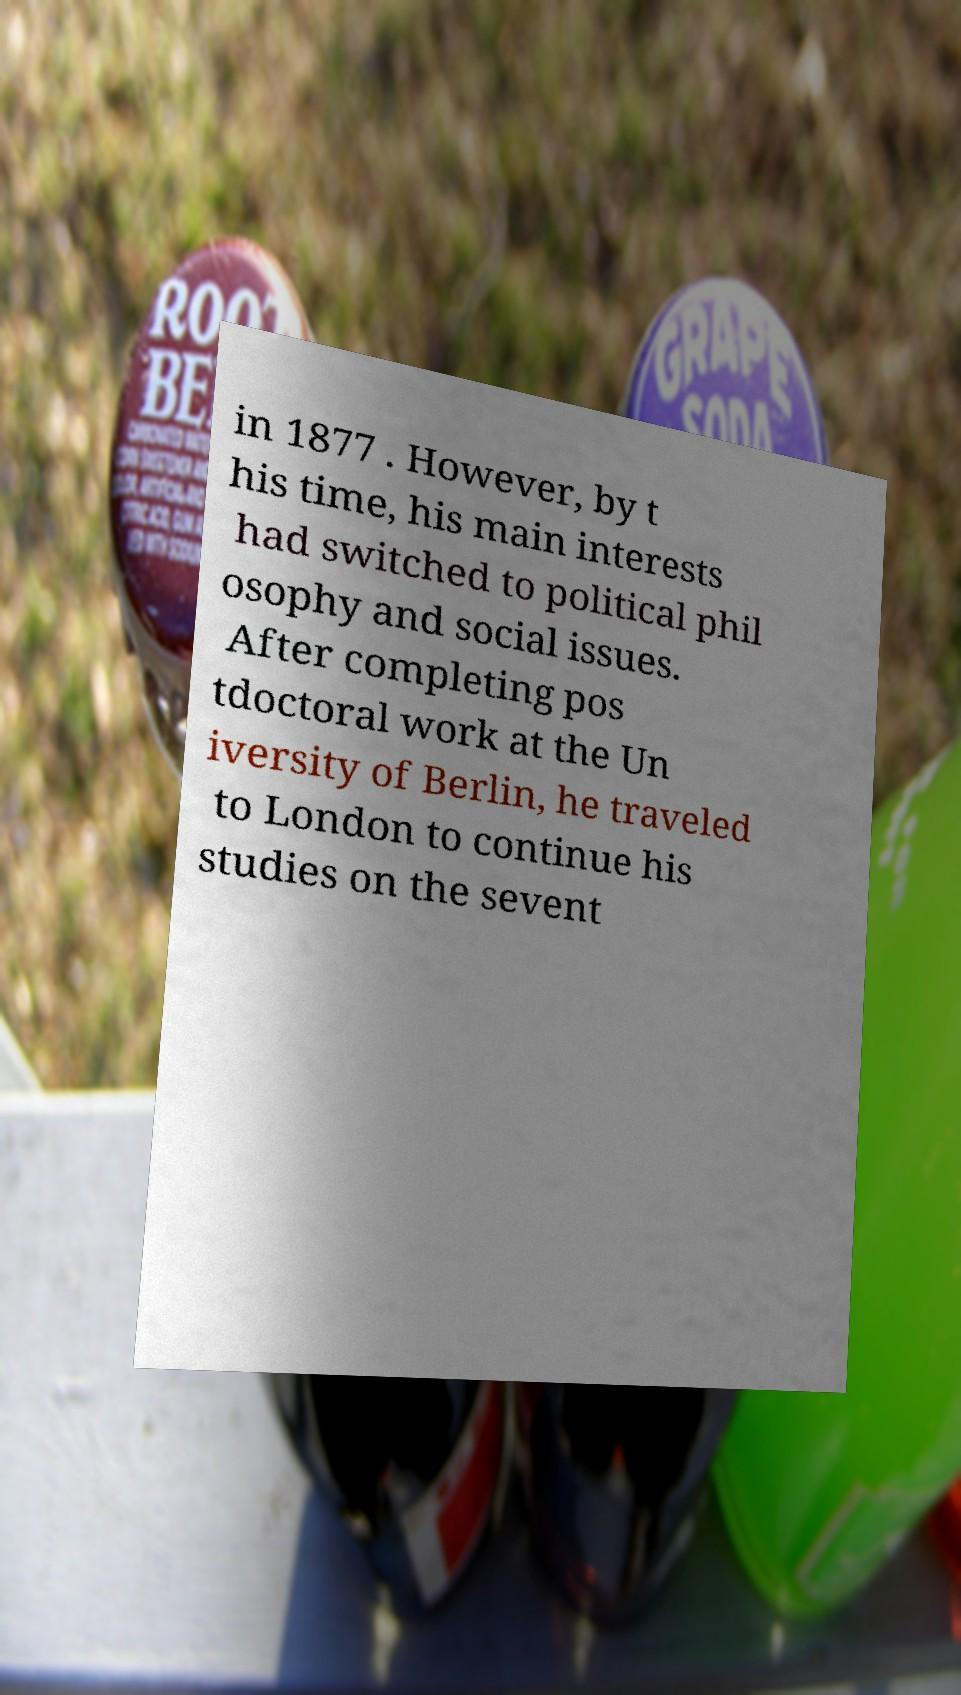Please read and relay the text visible in this image. What does it say? in 1877 . However, by t his time, his main interests had switched to political phil osophy and social issues. After completing pos tdoctoral work at the Un iversity of Berlin, he traveled to London to continue his studies on the sevent 